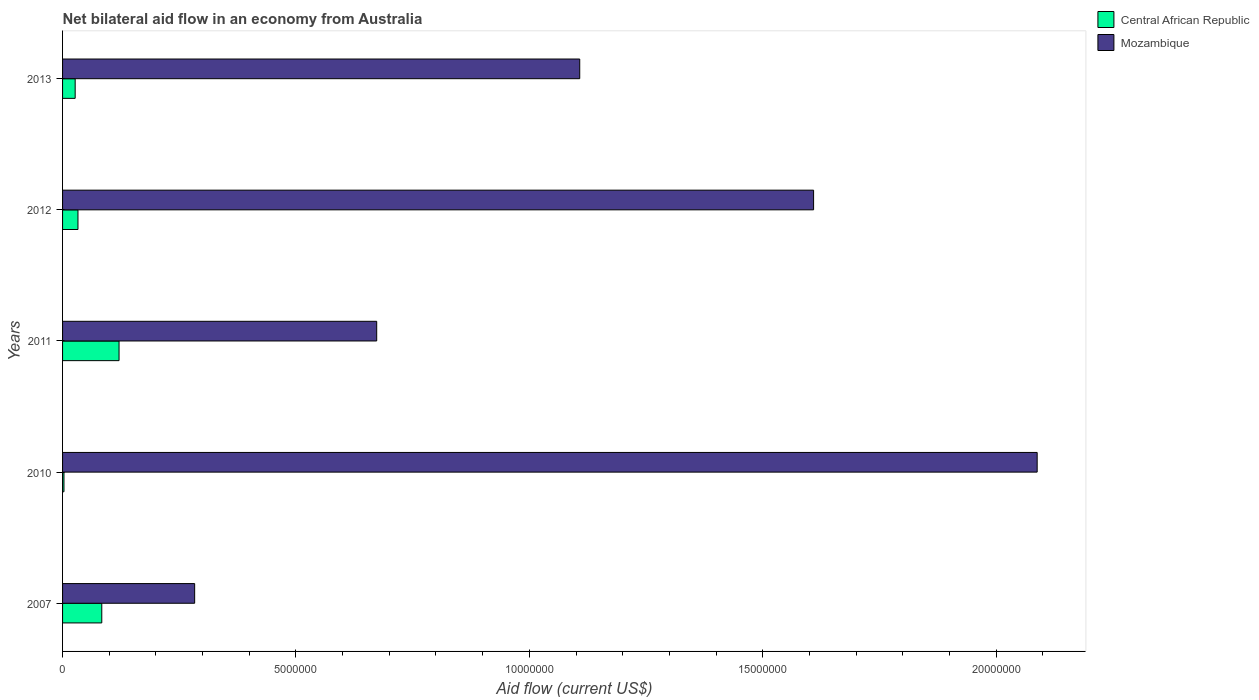How many different coloured bars are there?
Ensure brevity in your answer.  2. How many groups of bars are there?
Your answer should be compact. 5. Are the number of bars on each tick of the Y-axis equal?
Keep it short and to the point. Yes. How many bars are there on the 5th tick from the top?
Offer a very short reply. 2. How many bars are there on the 1st tick from the bottom?
Give a very brief answer. 2. Across all years, what is the maximum net bilateral aid flow in Mozambique?
Provide a short and direct response. 2.09e+07. Across all years, what is the minimum net bilateral aid flow in Mozambique?
Make the answer very short. 2.83e+06. In which year was the net bilateral aid flow in Mozambique minimum?
Your response must be concise. 2007. What is the total net bilateral aid flow in Mozambique in the graph?
Give a very brief answer. 5.76e+07. What is the difference between the net bilateral aid flow in Central African Republic in 2007 and that in 2011?
Your answer should be compact. -3.70e+05. What is the difference between the net bilateral aid flow in Mozambique in 2013 and the net bilateral aid flow in Central African Republic in 2012?
Offer a terse response. 1.08e+07. What is the average net bilateral aid flow in Central African Republic per year?
Provide a short and direct response. 5.36e+05. In the year 2011, what is the difference between the net bilateral aid flow in Central African Republic and net bilateral aid flow in Mozambique?
Give a very brief answer. -5.52e+06. In how many years, is the net bilateral aid flow in Mozambique greater than 16000000 US$?
Keep it short and to the point. 2. Is the difference between the net bilateral aid flow in Central African Republic in 2010 and 2013 greater than the difference between the net bilateral aid flow in Mozambique in 2010 and 2013?
Your answer should be compact. No. What is the difference between the highest and the second highest net bilateral aid flow in Mozambique?
Your response must be concise. 4.79e+06. What is the difference between the highest and the lowest net bilateral aid flow in Central African Republic?
Offer a very short reply. 1.18e+06. In how many years, is the net bilateral aid flow in Central African Republic greater than the average net bilateral aid flow in Central African Republic taken over all years?
Your answer should be very brief. 2. Is the sum of the net bilateral aid flow in Central African Republic in 2007 and 2012 greater than the maximum net bilateral aid flow in Mozambique across all years?
Your answer should be very brief. No. What does the 2nd bar from the top in 2013 represents?
Keep it short and to the point. Central African Republic. What does the 1st bar from the bottom in 2012 represents?
Offer a terse response. Central African Republic. How many bars are there?
Keep it short and to the point. 10. Does the graph contain grids?
Your response must be concise. No. Where does the legend appear in the graph?
Provide a succinct answer. Top right. What is the title of the graph?
Provide a short and direct response. Net bilateral aid flow in an economy from Australia. What is the label or title of the Y-axis?
Your response must be concise. Years. What is the Aid flow (current US$) of Central African Republic in 2007?
Offer a terse response. 8.40e+05. What is the Aid flow (current US$) of Mozambique in 2007?
Give a very brief answer. 2.83e+06. What is the Aid flow (current US$) in Central African Republic in 2010?
Offer a terse response. 3.00e+04. What is the Aid flow (current US$) in Mozambique in 2010?
Offer a very short reply. 2.09e+07. What is the Aid flow (current US$) of Central African Republic in 2011?
Ensure brevity in your answer.  1.21e+06. What is the Aid flow (current US$) in Mozambique in 2011?
Make the answer very short. 6.73e+06. What is the Aid flow (current US$) of Central African Republic in 2012?
Ensure brevity in your answer.  3.30e+05. What is the Aid flow (current US$) in Mozambique in 2012?
Your answer should be compact. 1.61e+07. What is the Aid flow (current US$) in Central African Republic in 2013?
Offer a very short reply. 2.70e+05. What is the Aid flow (current US$) in Mozambique in 2013?
Keep it short and to the point. 1.11e+07. Across all years, what is the maximum Aid flow (current US$) of Central African Republic?
Ensure brevity in your answer.  1.21e+06. Across all years, what is the maximum Aid flow (current US$) of Mozambique?
Make the answer very short. 2.09e+07. Across all years, what is the minimum Aid flow (current US$) of Central African Republic?
Offer a terse response. 3.00e+04. Across all years, what is the minimum Aid flow (current US$) of Mozambique?
Offer a very short reply. 2.83e+06. What is the total Aid flow (current US$) of Central African Republic in the graph?
Provide a succinct answer. 2.68e+06. What is the total Aid flow (current US$) in Mozambique in the graph?
Keep it short and to the point. 5.76e+07. What is the difference between the Aid flow (current US$) of Central African Republic in 2007 and that in 2010?
Provide a succinct answer. 8.10e+05. What is the difference between the Aid flow (current US$) of Mozambique in 2007 and that in 2010?
Provide a succinct answer. -1.80e+07. What is the difference between the Aid flow (current US$) in Central African Republic in 2007 and that in 2011?
Your answer should be very brief. -3.70e+05. What is the difference between the Aid flow (current US$) of Mozambique in 2007 and that in 2011?
Keep it short and to the point. -3.90e+06. What is the difference between the Aid flow (current US$) in Central African Republic in 2007 and that in 2012?
Make the answer very short. 5.10e+05. What is the difference between the Aid flow (current US$) of Mozambique in 2007 and that in 2012?
Give a very brief answer. -1.33e+07. What is the difference between the Aid flow (current US$) in Central African Republic in 2007 and that in 2013?
Provide a succinct answer. 5.70e+05. What is the difference between the Aid flow (current US$) in Mozambique in 2007 and that in 2013?
Offer a very short reply. -8.25e+06. What is the difference between the Aid flow (current US$) of Central African Republic in 2010 and that in 2011?
Your answer should be compact. -1.18e+06. What is the difference between the Aid flow (current US$) of Mozambique in 2010 and that in 2011?
Ensure brevity in your answer.  1.42e+07. What is the difference between the Aid flow (current US$) in Mozambique in 2010 and that in 2012?
Ensure brevity in your answer.  4.79e+06. What is the difference between the Aid flow (current US$) in Central African Republic in 2010 and that in 2013?
Make the answer very short. -2.40e+05. What is the difference between the Aid flow (current US$) in Mozambique in 2010 and that in 2013?
Your response must be concise. 9.80e+06. What is the difference between the Aid flow (current US$) of Central African Republic in 2011 and that in 2012?
Your response must be concise. 8.80e+05. What is the difference between the Aid flow (current US$) of Mozambique in 2011 and that in 2012?
Offer a terse response. -9.36e+06. What is the difference between the Aid flow (current US$) in Central African Republic in 2011 and that in 2013?
Ensure brevity in your answer.  9.40e+05. What is the difference between the Aid flow (current US$) of Mozambique in 2011 and that in 2013?
Make the answer very short. -4.35e+06. What is the difference between the Aid flow (current US$) in Mozambique in 2012 and that in 2013?
Offer a terse response. 5.01e+06. What is the difference between the Aid flow (current US$) in Central African Republic in 2007 and the Aid flow (current US$) in Mozambique in 2010?
Ensure brevity in your answer.  -2.00e+07. What is the difference between the Aid flow (current US$) in Central African Republic in 2007 and the Aid flow (current US$) in Mozambique in 2011?
Make the answer very short. -5.89e+06. What is the difference between the Aid flow (current US$) of Central African Republic in 2007 and the Aid flow (current US$) of Mozambique in 2012?
Make the answer very short. -1.52e+07. What is the difference between the Aid flow (current US$) in Central African Republic in 2007 and the Aid flow (current US$) in Mozambique in 2013?
Ensure brevity in your answer.  -1.02e+07. What is the difference between the Aid flow (current US$) of Central African Republic in 2010 and the Aid flow (current US$) of Mozambique in 2011?
Your answer should be compact. -6.70e+06. What is the difference between the Aid flow (current US$) of Central African Republic in 2010 and the Aid flow (current US$) of Mozambique in 2012?
Your answer should be compact. -1.61e+07. What is the difference between the Aid flow (current US$) of Central African Republic in 2010 and the Aid flow (current US$) of Mozambique in 2013?
Your response must be concise. -1.10e+07. What is the difference between the Aid flow (current US$) in Central African Republic in 2011 and the Aid flow (current US$) in Mozambique in 2012?
Offer a terse response. -1.49e+07. What is the difference between the Aid flow (current US$) of Central African Republic in 2011 and the Aid flow (current US$) of Mozambique in 2013?
Your answer should be compact. -9.87e+06. What is the difference between the Aid flow (current US$) of Central African Republic in 2012 and the Aid flow (current US$) of Mozambique in 2013?
Offer a terse response. -1.08e+07. What is the average Aid flow (current US$) in Central African Republic per year?
Provide a short and direct response. 5.36e+05. What is the average Aid flow (current US$) of Mozambique per year?
Ensure brevity in your answer.  1.15e+07. In the year 2007, what is the difference between the Aid flow (current US$) in Central African Republic and Aid flow (current US$) in Mozambique?
Ensure brevity in your answer.  -1.99e+06. In the year 2010, what is the difference between the Aid flow (current US$) in Central African Republic and Aid flow (current US$) in Mozambique?
Your answer should be very brief. -2.08e+07. In the year 2011, what is the difference between the Aid flow (current US$) of Central African Republic and Aid flow (current US$) of Mozambique?
Offer a terse response. -5.52e+06. In the year 2012, what is the difference between the Aid flow (current US$) in Central African Republic and Aid flow (current US$) in Mozambique?
Give a very brief answer. -1.58e+07. In the year 2013, what is the difference between the Aid flow (current US$) of Central African Republic and Aid flow (current US$) of Mozambique?
Ensure brevity in your answer.  -1.08e+07. What is the ratio of the Aid flow (current US$) of Mozambique in 2007 to that in 2010?
Offer a terse response. 0.14. What is the ratio of the Aid flow (current US$) of Central African Republic in 2007 to that in 2011?
Your answer should be very brief. 0.69. What is the ratio of the Aid flow (current US$) of Mozambique in 2007 to that in 2011?
Your response must be concise. 0.42. What is the ratio of the Aid flow (current US$) in Central African Republic in 2007 to that in 2012?
Make the answer very short. 2.55. What is the ratio of the Aid flow (current US$) of Mozambique in 2007 to that in 2012?
Your answer should be very brief. 0.18. What is the ratio of the Aid flow (current US$) of Central African Republic in 2007 to that in 2013?
Give a very brief answer. 3.11. What is the ratio of the Aid flow (current US$) in Mozambique in 2007 to that in 2013?
Provide a succinct answer. 0.26. What is the ratio of the Aid flow (current US$) of Central African Republic in 2010 to that in 2011?
Provide a succinct answer. 0.02. What is the ratio of the Aid flow (current US$) in Mozambique in 2010 to that in 2011?
Keep it short and to the point. 3.1. What is the ratio of the Aid flow (current US$) in Central African Republic in 2010 to that in 2012?
Provide a succinct answer. 0.09. What is the ratio of the Aid flow (current US$) in Mozambique in 2010 to that in 2012?
Give a very brief answer. 1.3. What is the ratio of the Aid flow (current US$) in Mozambique in 2010 to that in 2013?
Give a very brief answer. 1.88. What is the ratio of the Aid flow (current US$) of Central African Republic in 2011 to that in 2012?
Your answer should be compact. 3.67. What is the ratio of the Aid flow (current US$) of Mozambique in 2011 to that in 2012?
Your answer should be compact. 0.42. What is the ratio of the Aid flow (current US$) in Central African Republic in 2011 to that in 2013?
Your answer should be very brief. 4.48. What is the ratio of the Aid flow (current US$) in Mozambique in 2011 to that in 2013?
Your answer should be compact. 0.61. What is the ratio of the Aid flow (current US$) of Central African Republic in 2012 to that in 2013?
Keep it short and to the point. 1.22. What is the ratio of the Aid flow (current US$) in Mozambique in 2012 to that in 2013?
Give a very brief answer. 1.45. What is the difference between the highest and the second highest Aid flow (current US$) in Mozambique?
Make the answer very short. 4.79e+06. What is the difference between the highest and the lowest Aid flow (current US$) in Central African Republic?
Offer a terse response. 1.18e+06. What is the difference between the highest and the lowest Aid flow (current US$) in Mozambique?
Make the answer very short. 1.80e+07. 